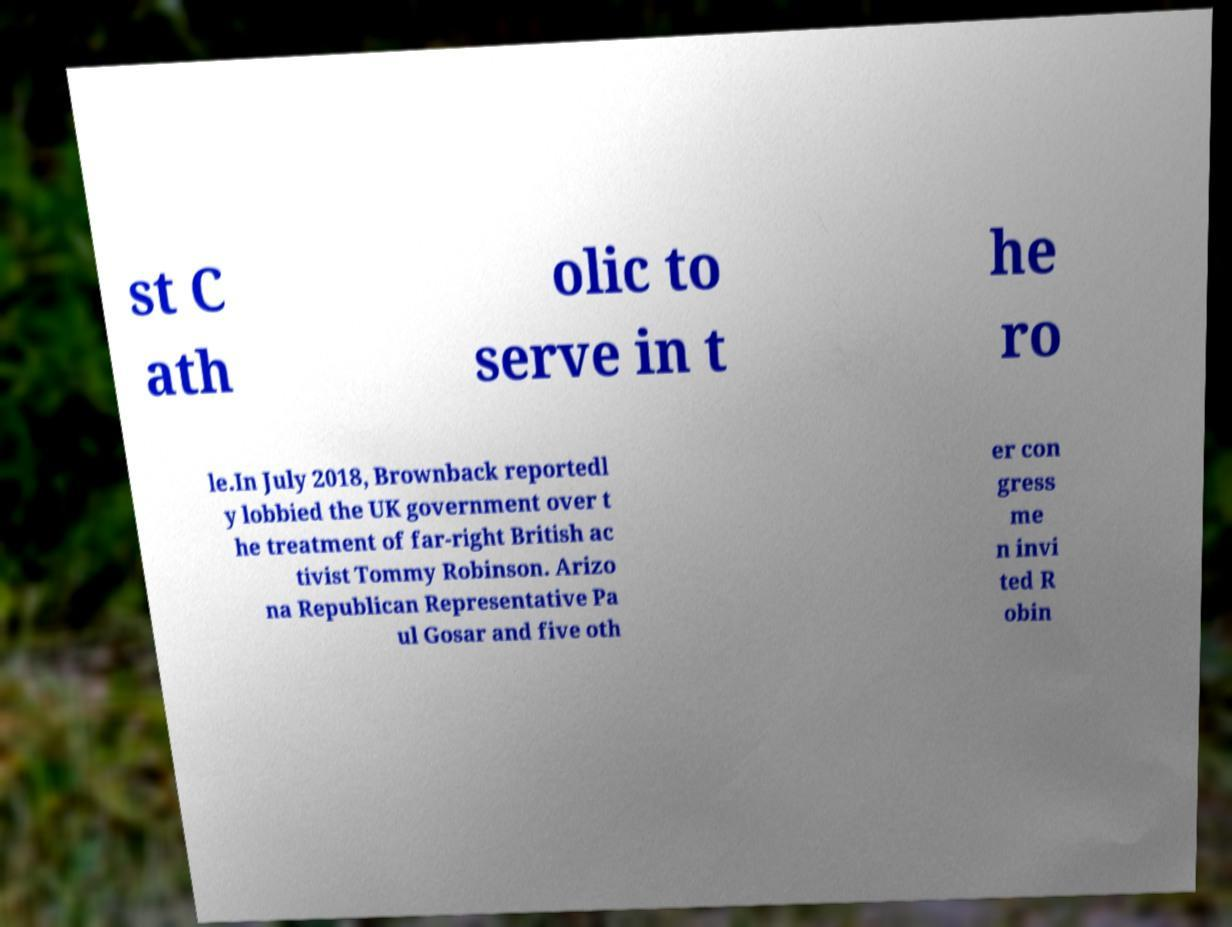Could you assist in decoding the text presented in this image and type it out clearly? st C ath olic to serve in t he ro le.In July 2018, Brownback reportedl y lobbied the UK government over t he treatment of far-right British ac tivist Tommy Robinson. Arizo na Republican Representative Pa ul Gosar and five oth er con gress me n invi ted R obin 